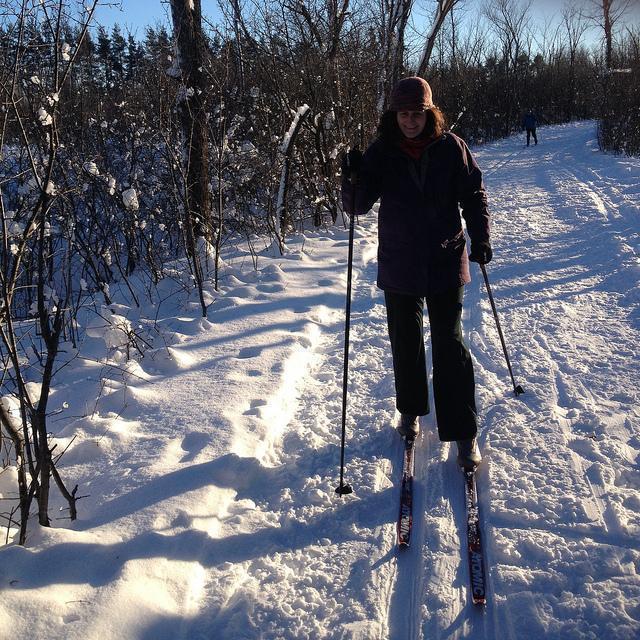What is making the thin lines in the snow?
Make your selection from the four choices given to correctly answer the question.
Options: Snakes, birds, tires, skis. Skis. 